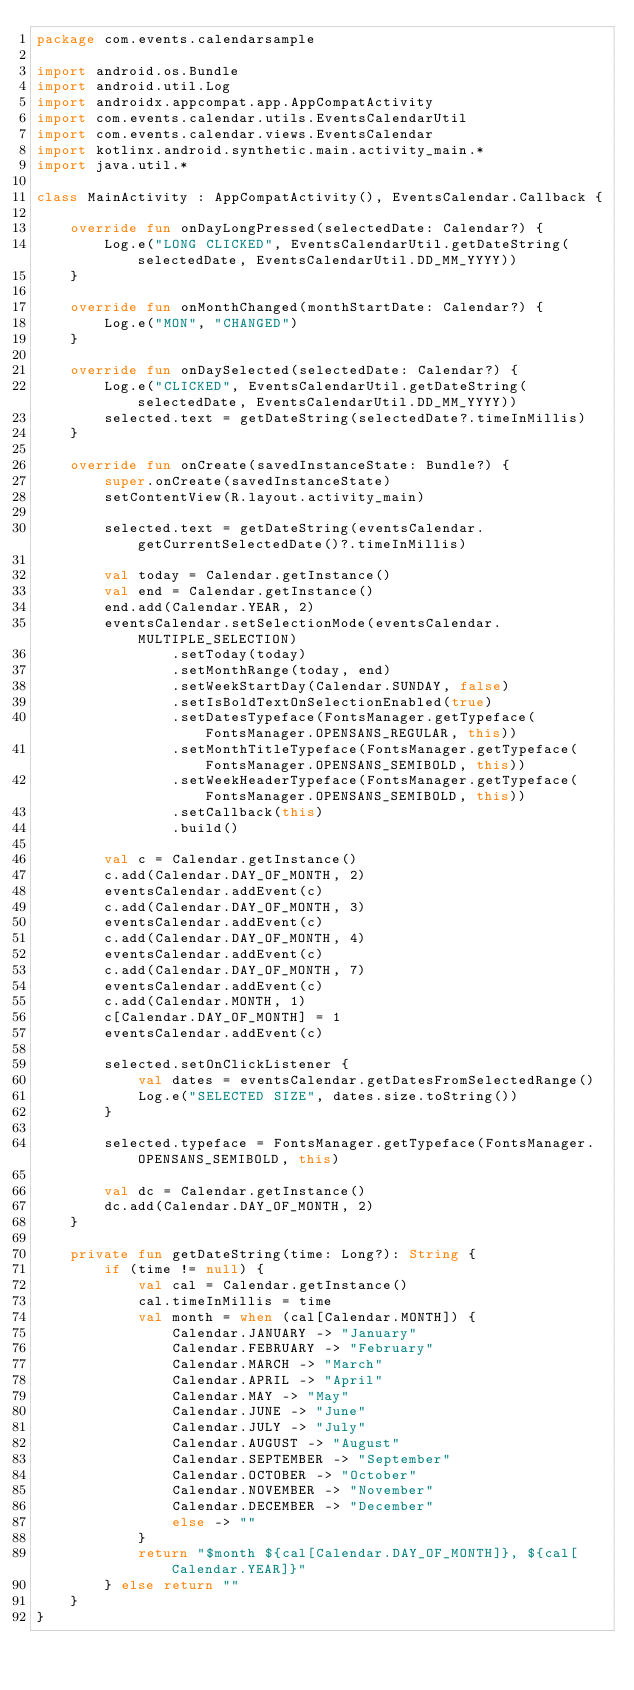<code> <loc_0><loc_0><loc_500><loc_500><_Kotlin_>package com.events.calendarsample

import android.os.Bundle
import android.util.Log
import androidx.appcompat.app.AppCompatActivity
import com.events.calendar.utils.EventsCalendarUtil
import com.events.calendar.views.EventsCalendar
import kotlinx.android.synthetic.main.activity_main.*
import java.util.*

class MainActivity : AppCompatActivity(), EventsCalendar.Callback {

    override fun onDayLongPressed(selectedDate: Calendar?) {
        Log.e("LONG CLICKED", EventsCalendarUtil.getDateString(selectedDate, EventsCalendarUtil.DD_MM_YYYY))
    }

    override fun onMonthChanged(monthStartDate: Calendar?) {
        Log.e("MON", "CHANGED")
    }

    override fun onDaySelected(selectedDate: Calendar?) {
        Log.e("CLICKED", EventsCalendarUtil.getDateString(selectedDate, EventsCalendarUtil.DD_MM_YYYY))
        selected.text = getDateString(selectedDate?.timeInMillis)
    }

    override fun onCreate(savedInstanceState: Bundle?) {
        super.onCreate(savedInstanceState)
        setContentView(R.layout.activity_main)

        selected.text = getDateString(eventsCalendar.getCurrentSelectedDate()?.timeInMillis)

        val today = Calendar.getInstance()
        val end = Calendar.getInstance()
        end.add(Calendar.YEAR, 2)
        eventsCalendar.setSelectionMode(eventsCalendar.MULTIPLE_SELECTION)
                .setToday(today)
                .setMonthRange(today, end)
                .setWeekStartDay(Calendar.SUNDAY, false)
                .setIsBoldTextOnSelectionEnabled(true)
                .setDatesTypeface(FontsManager.getTypeface(FontsManager.OPENSANS_REGULAR, this))
                .setMonthTitleTypeface(FontsManager.getTypeface(FontsManager.OPENSANS_SEMIBOLD, this))
                .setWeekHeaderTypeface(FontsManager.getTypeface(FontsManager.OPENSANS_SEMIBOLD, this))
                .setCallback(this)
                .build()

        val c = Calendar.getInstance()
        c.add(Calendar.DAY_OF_MONTH, 2)
        eventsCalendar.addEvent(c)
        c.add(Calendar.DAY_OF_MONTH, 3)
        eventsCalendar.addEvent(c)
        c.add(Calendar.DAY_OF_MONTH, 4)
        eventsCalendar.addEvent(c)
        c.add(Calendar.DAY_OF_MONTH, 7)
        eventsCalendar.addEvent(c)
        c.add(Calendar.MONTH, 1)
        c[Calendar.DAY_OF_MONTH] = 1
        eventsCalendar.addEvent(c)

        selected.setOnClickListener {
            val dates = eventsCalendar.getDatesFromSelectedRange()
            Log.e("SELECTED SIZE", dates.size.toString())
        }

        selected.typeface = FontsManager.getTypeface(FontsManager.OPENSANS_SEMIBOLD, this)

        val dc = Calendar.getInstance()
        dc.add(Calendar.DAY_OF_MONTH, 2)
    }

    private fun getDateString(time: Long?): String {
        if (time != null) {
            val cal = Calendar.getInstance()
            cal.timeInMillis = time
            val month = when (cal[Calendar.MONTH]) {
                Calendar.JANUARY -> "January"
                Calendar.FEBRUARY -> "February"
                Calendar.MARCH -> "March"
                Calendar.APRIL -> "April"
                Calendar.MAY -> "May"
                Calendar.JUNE -> "June"
                Calendar.JULY -> "July"
                Calendar.AUGUST -> "August"
                Calendar.SEPTEMBER -> "September"
                Calendar.OCTOBER -> "October"
                Calendar.NOVEMBER -> "November"
                Calendar.DECEMBER -> "December"
                else -> ""
            }
            return "$month ${cal[Calendar.DAY_OF_MONTH]}, ${cal[Calendar.YEAR]}"
        } else return ""
    }
}
</code> 